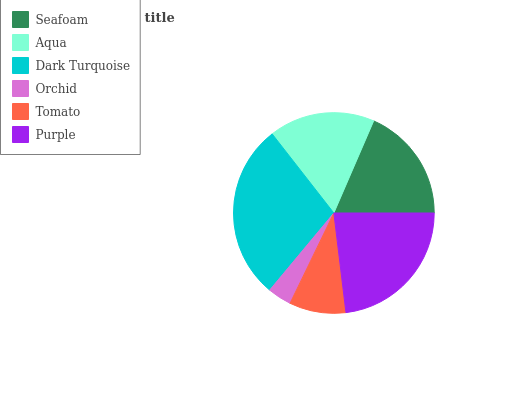Is Orchid the minimum?
Answer yes or no. Yes. Is Dark Turquoise the maximum?
Answer yes or no. Yes. Is Aqua the minimum?
Answer yes or no. No. Is Aqua the maximum?
Answer yes or no. No. Is Seafoam greater than Aqua?
Answer yes or no. Yes. Is Aqua less than Seafoam?
Answer yes or no. Yes. Is Aqua greater than Seafoam?
Answer yes or no. No. Is Seafoam less than Aqua?
Answer yes or no. No. Is Seafoam the high median?
Answer yes or no. Yes. Is Aqua the low median?
Answer yes or no. Yes. Is Orchid the high median?
Answer yes or no. No. Is Tomato the low median?
Answer yes or no. No. 